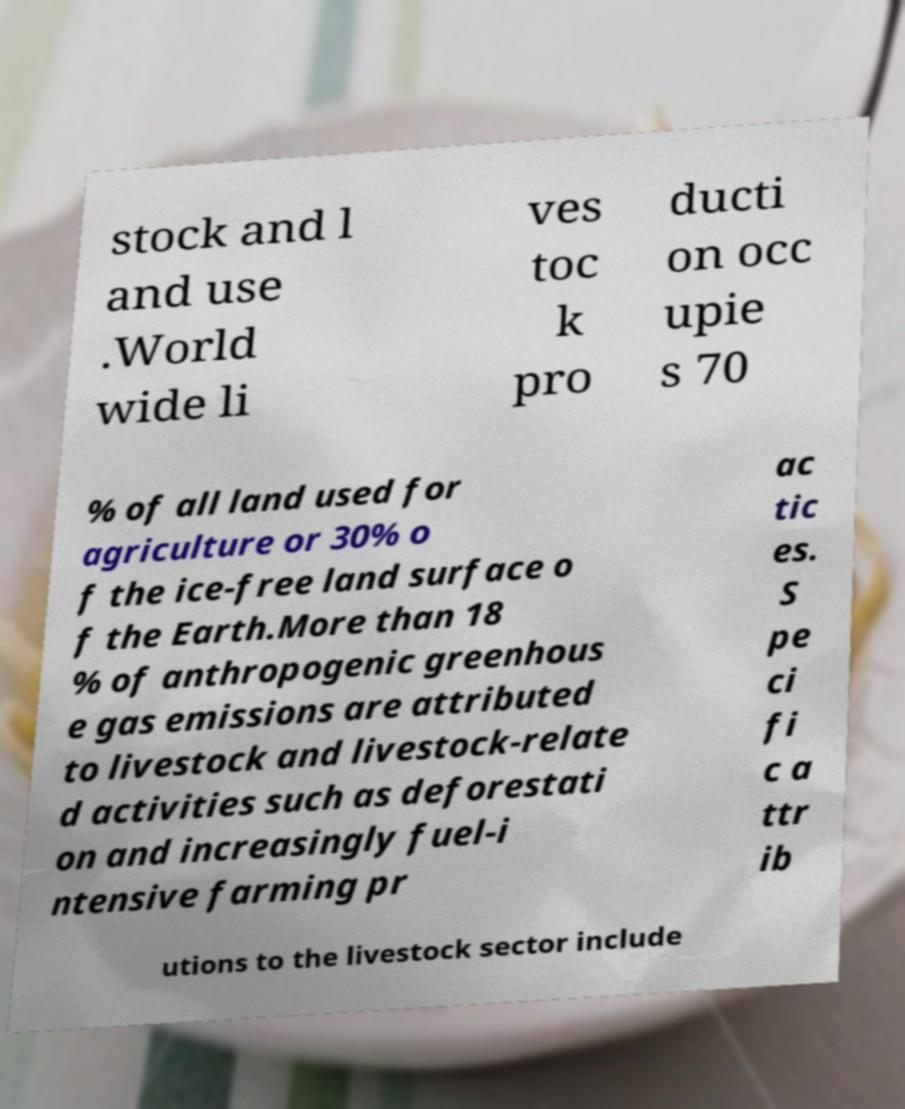Could you assist in decoding the text presented in this image and type it out clearly? stock and l and use .World wide li ves toc k pro ducti on occ upie s 70 % of all land used for agriculture or 30% o f the ice-free land surface o f the Earth.More than 18 % of anthropogenic greenhous e gas emissions are attributed to livestock and livestock-relate d activities such as deforestati on and increasingly fuel-i ntensive farming pr ac tic es. S pe ci fi c a ttr ib utions to the livestock sector include 